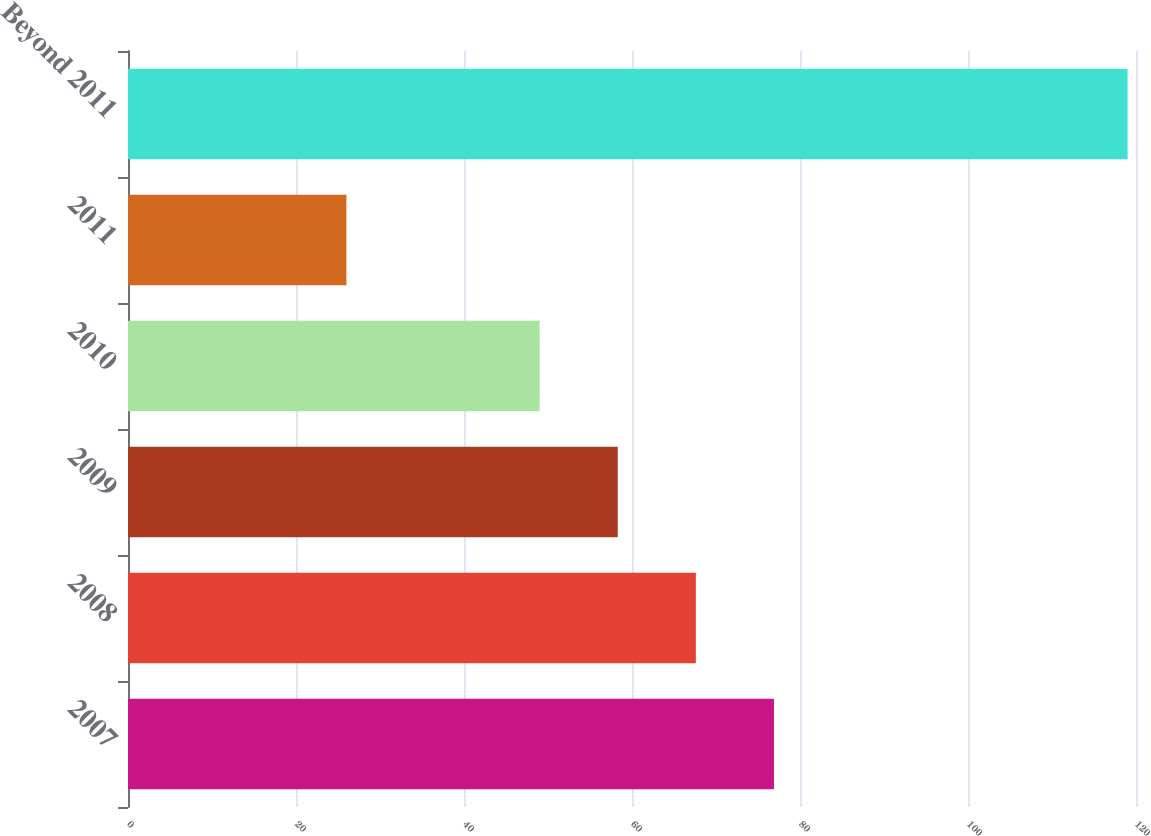<chart> <loc_0><loc_0><loc_500><loc_500><bar_chart><fcel>2007<fcel>2008<fcel>2009<fcel>2010<fcel>2011<fcel>Beyond 2011<nl><fcel>76.9<fcel>67.6<fcel>58.3<fcel>49<fcel>26<fcel>119<nl></chart> 